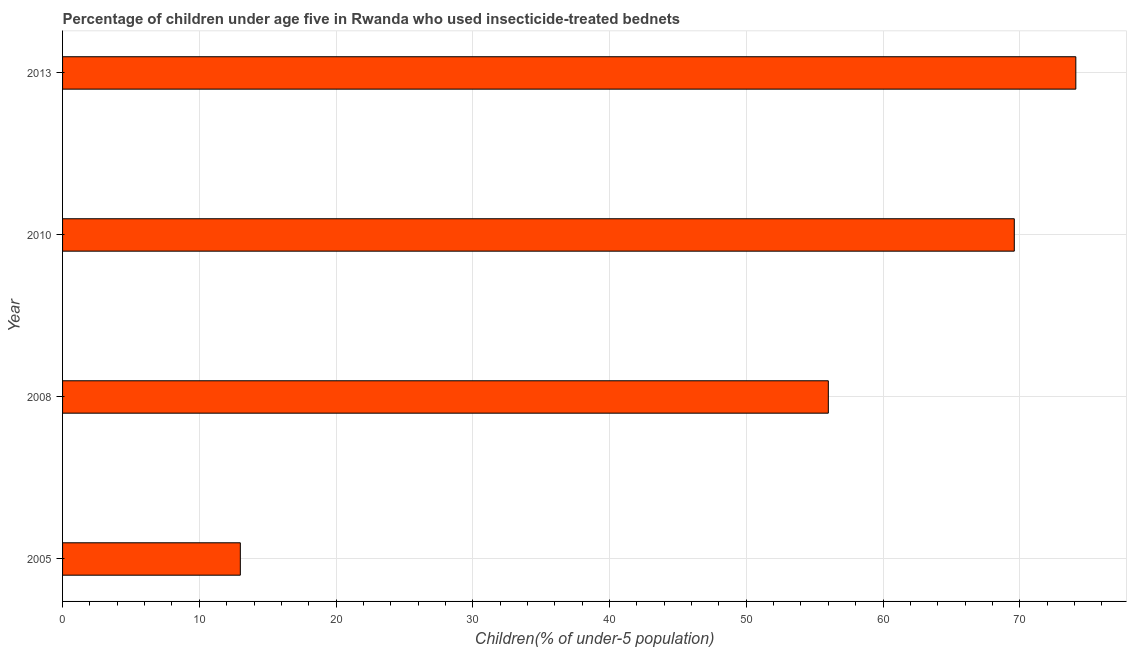Does the graph contain any zero values?
Your answer should be very brief. No. What is the title of the graph?
Make the answer very short. Percentage of children under age five in Rwanda who used insecticide-treated bednets. What is the label or title of the X-axis?
Your response must be concise. Children(% of under-5 population). What is the percentage of children who use of insecticide-treated bed nets in 2005?
Your answer should be compact. 13. Across all years, what is the maximum percentage of children who use of insecticide-treated bed nets?
Provide a succinct answer. 74.1. Across all years, what is the minimum percentage of children who use of insecticide-treated bed nets?
Offer a terse response. 13. What is the sum of the percentage of children who use of insecticide-treated bed nets?
Keep it short and to the point. 212.7. What is the difference between the percentage of children who use of insecticide-treated bed nets in 2005 and 2008?
Offer a terse response. -43. What is the average percentage of children who use of insecticide-treated bed nets per year?
Give a very brief answer. 53.17. What is the median percentage of children who use of insecticide-treated bed nets?
Ensure brevity in your answer.  62.8. What is the ratio of the percentage of children who use of insecticide-treated bed nets in 2005 to that in 2010?
Keep it short and to the point. 0.19. Is the percentage of children who use of insecticide-treated bed nets in 2010 less than that in 2013?
Keep it short and to the point. Yes. Is the sum of the percentage of children who use of insecticide-treated bed nets in 2005 and 2013 greater than the maximum percentage of children who use of insecticide-treated bed nets across all years?
Provide a short and direct response. Yes. What is the difference between the highest and the lowest percentage of children who use of insecticide-treated bed nets?
Your answer should be very brief. 61.1. How many bars are there?
Keep it short and to the point. 4. How many years are there in the graph?
Your answer should be very brief. 4. What is the difference between two consecutive major ticks on the X-axis?
Keep it short and to the point. 10. What is the Children(% of under-5 population) of 2005?
Make the answer very short. 13. What is the Children(% of under-5 population) in 2010?
Provide a short and direct response. 69.6. What is the Children(% of under-5 population) in 2013?
Provide a succinct answer. 74.1. What is the difference between the Children(% of under-5 population) in 2005 and 2008?
Your answer should be compact. -43. What is the difference between the Children(% of under-5 population) in 2005 and 2010?
Give a very brief answer. -56.6. What is the difference between the Children(% of under-5 population) in 2005 and 2013?
Your response must be concise. -61.1. What is the difference between the Children(% of under-5 population) in 2008 and 2010?
Ensure brevity in your answer.  -13.6. What is the difference between the Children(% of under-5 population) in 2008 and 2013?
Provide a short and direct response. -18.1. What is the difference between the Children(% of under-5 population) in 2010 and 2013?
Offer a terse response. -4.5. What is the ratio of the Children(% of under-5 population) in 2005 to that in 2008?
Offer a terse response. 0.23. What is the ratio of the Children(% of under-5 population) in 2005 to that in 2010?
Your answer should be very brief. 0.19. What is the ratio of the Children(% of under-5 population) in 2005 to that in 2013?
Offer a very short reply. 0.17. What is the ratio of the Children(% of under-5 population) in 2008 to that in 2010?
Keep it short and to the point. 0.81. What is the ratio of the Children(% of under-5 population) in 2008 to that in 2013?
Ensure brevity in your answer.  0.76. What is the ratio of the Children(% of under-5 population) in 2010 to that in 2013?
Give a very brief answer. 0.94. 